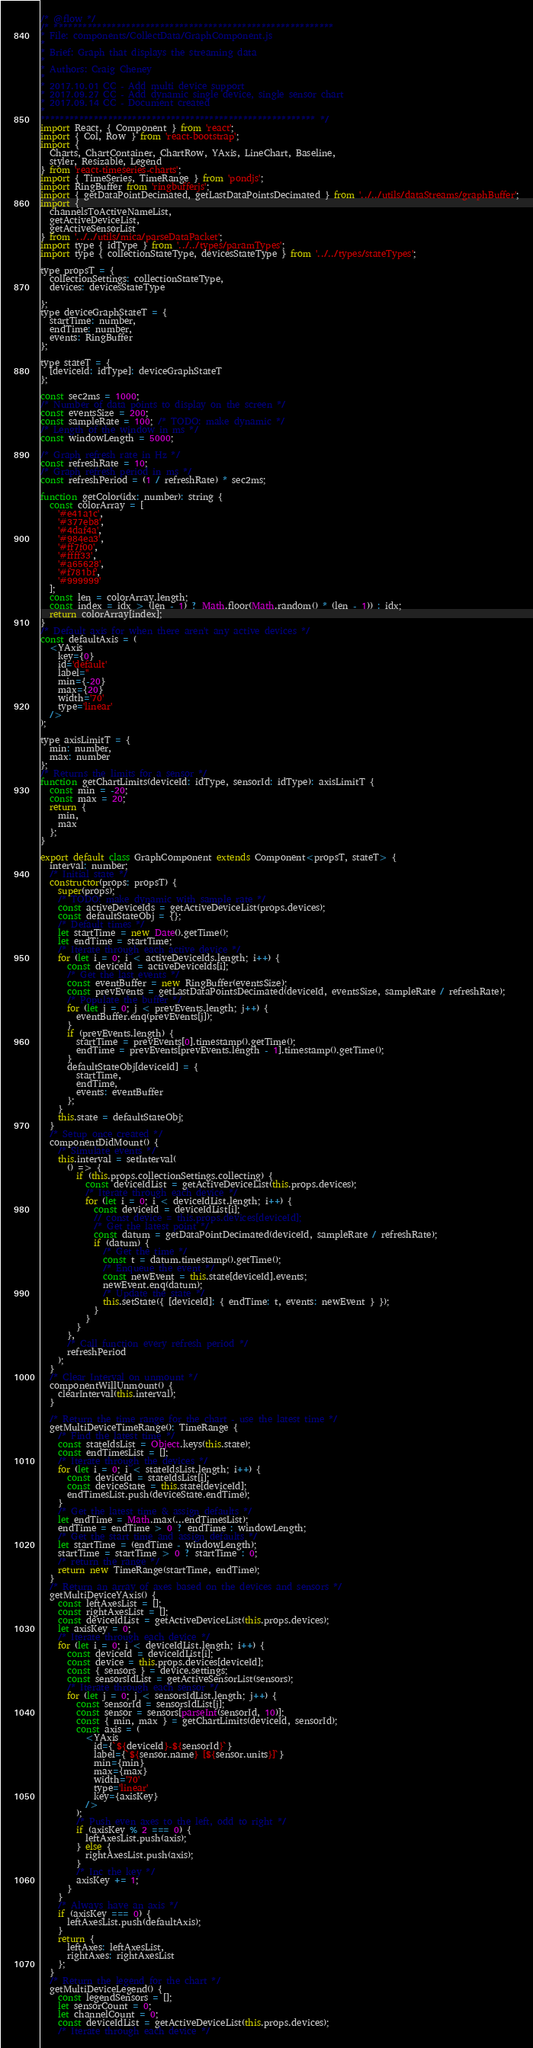Convert code to text. <code><loc_0><loc_0><loc_500><loc_500><_JavaScript_>/* @flow */
/* **********************************************************
* File: components/CollectData/GraphComponent.js
*
* Brief: Graph that displays the streaming data
*
* Authors: Craig Cheney
*
* 2017.10.01 CC - Add multi device support
* 2017.09.27 CC - Add dynamic single device, single sensor chart
* 2017.09.14 CC - Document created
*
********************************************************* */
import React, { Component } from 'react';
import { Col, Row } from 'react-bootstrap';
import {
  Charts, ChartContainer, ChartRow, YAxis, LineChart, Baseline,
  styler, Resizable, Legend
} from 'react-timeseries-charts';
import { TimeSeries, TimeRange } from 'pondjs';
import RingBuffer from 'ringbufferjs';
import { getDataPointDecimated, getLastDataPointsDecimated } from '../../utils/dataStreams/graphBuffer';
import {
  channelsToActiveNameList,
  getActiveDeviceList,
  getActiveSensorList
} from '../../utils/mica/parseDataPacket';
import type { idType } from '../../types/paramTypes';
import type { collectionStateType, devicesStateType } from '../../types/stateTypes';

type propsT = {
  collectionSettings: collectionStateType,
  devices: devicesStateType

};
type deviceGraphStateT = {
  startTime: number,
  endTime: number,
  events: RingBuffer
};

type stateT = {
  [deviceId: idType]: deviceGraphStateT
};

const sec2ms = 1000;
/* Number of data points to display on the screen */
const eventsSize = 200;
const sampleRate = 100; /* TODO: make dynamic */
/* Length of the window in ms */
const windowLength = 5000;

/* Graph refresh rate in Hz */
const refreshRate = 10;
/* Graph refresh period in ms */
const refreshPeriod = (1 / refreshRate) * sec2ms;

function getColor(idx: number): string {
  const colorArray = [
    '#e41a1c',
    '#377eb8',
    '#4daf4a',
    '#984ea3',
    '#ff7f00',
    '#ffff33',
    '#a65628',
    '#f781bf',
    '#999999'
  ];
  const len = colorArray.length;
  const index = idx > (len - 1) ? Math.floor(Math.random() * (len - 1)) : idx;
  return colorArray[index];
}
/* Default axis for when there aren't any active devices */
const defaultAxis = (
  <YAxis
    key={0}
    id='default'
    label=''
    min={-20}
    max={20}
    width='70'
    type='linear'
  />
);

type axisLimitT = {
  min: number,
  max: number
};
/* Returns the limits for a sensor */
function getChartLimits(deviceId: idType, sensorId: idType): axisLimitT {
  const min = -20;
  const max = 20;
  return {
    min,
    max
  };
}

export default class GraphComponent extends Component<propsT, stateT> {
  interval: number;
  /* Initial state */
  constructor(props: propsT) {
    super(props);
    /* TODO: make dynamic with sample rate */
    const activeDeviceIds = getActiveDeviceList(props.devices);
    const defaultStateObj = {};
    /* Default times */
    let startTime = new Date().getTime();
    let endTime = startTime;
    /* Iterate through each active device */
    for (let i = 0; i < activeDeviceIds.length; i++) {
      const deviceId = activeDeviceIds[i];
      /* Get the last events */
      const eventBuffer = new RingBuffer(eventsSize);
      const prevEvents = getLastDataPointsDecimated(deviceId, eventsSize, sampleRate / refreshRate);
      /* Populate the buffer */
      for (let j = 0; j < prevEvents.length; j++) {
        eventBuffer.enq(prevEvents[j]);
      }
      if (prevEvents.length) {
        startTime = prevEvents[0].timestamp().getTime();
        endTime = prevEvents[prevEvents.length - 1].timestamp().getTime();
      }
      defaultStateObj[deviceId] = {
        startTime,
        endTime,
        events: eventBuffer
      };
    }
    this.state = defaultStateObj;
  }
  /* Setup once created */
  componentDidMount() {
    /* Simulate events */
    this.interval = setInterval(
      () => {
        if (this.props.collectionSettings.collecting) {
          const deviceIdList = getActiveDeviceList(this.props.devices);
          /* Iterate through each device */
          for (let i = 0; i < deviceIdList.length; i++) {
            const deviceId = deviceIdList[i];
            // const device = this.props.devices[deviceId];
            /* Get the latest point */
            const datum = getDataPointDecimated(deviceId, sampleRate / refreshRate);
            if (datum) {
              /* Get the time */
              const t = datum.timestamp().getTime();
              /* Enqueue the event */
              const newEvent = this.state[deviceId].events;
              newEvent.enq(datum);
              /* Update the state */
              this.setState({ [deviceId]: { endTime: t, events: newEvent } });
            }
          }
        }
      },
      /* Call function every refresh period */
      refreshPeriod
    );
  }
  /* Clear Interval on unmount */
  componentWillUnmount() {
    clearInterval(this.interval);
  }

  /* Return the time range for the chart - use the latest time */
  getMultiDeviceTimeRange(): TimeRange {
    /* Find the latest time */
    const stateIdsList = Object.keys(this.state);
    const endTimesList = [];
    /* Iterate through the devices */
    for (let i = 0; i < stateIdsList.length; i++) {
      const deviceId = stateIdsList[i];
      const deviceState = this.state[deviceId];
      endTimesList.push(deviceState.endTime);
    }
    /* Get the latest time & assign defaults */
    let endTime = Math.max(...endTimesList);
    endTime = endTime > 0 ? endTime : windowLength;
    /* Get the start time and assign defaults */
    let startTime = (endTime - windowLength);
    startTime = startTime > 0 ? startTime : 0;
    /* return the range */
    return new TimeRange(startTime, endTime);
  }
  /* Return an array of axes based on the devices and sensors */
  getMultiDeviceYAxis() {
    const leftAxesList = [];
    const rightAxesList = [];
    const deviceIdList = getActiveDeviceList(this.props.devices);
    let axisKey = 0;
    /* Iterate through each device */
    for (let i = 0; i < deviceIdList.length; i++) {
      const deviceId = deviceIdList[i];
      const device = this.props.devices[deviceId];
      const { sensors } = device.settings;
      const sensorsIdList = getActiveSensorList(sensors);
      /* Iterate through each sensor */
      for (let j = 0; j < sensorsIdList.length; j++) {
        const sensorId = sensorsIdList[j];
        const sensor = sensors[parseInt(sensorId, 10)];
        const { min, max } = getChartLimits(deviceId, sensorId);
        const axis = (
          <YAxis
            id={`${deviceId}-${sensorId}`}
            label={`${sensor.name} [${sensor.units}]`}
            min={min}
            max={max}
            width='70'
            type='linear'
            key={axisKey}
          />
        );
        /* Push even axes to the left, odd to right */
        if (axisKey % 2 === 0) {
          leftAxesList.push(axis);
        } else {
          rightAxesList.push(axis);
        }
        /* Inc the key */
        axisKey += 1;
      }
    }
    /* Always have an axis */
    if (axisKey === 0) {
      leftAxesList.push(defaultAxis);
    }
    return {
      leftAxes: leftAxesList,
      rightAxes: rightAxesList
    };
  }
  /* Return the legend for the chart */
  getMultiDeviceLegend() {
    const legendSensors = [];
    let sensorCount = 0;
    let channelCount = 0;
    const deviceIdList = getActiveDeviceList(this.props.devices);
    /* Iterate through each device */</code> 